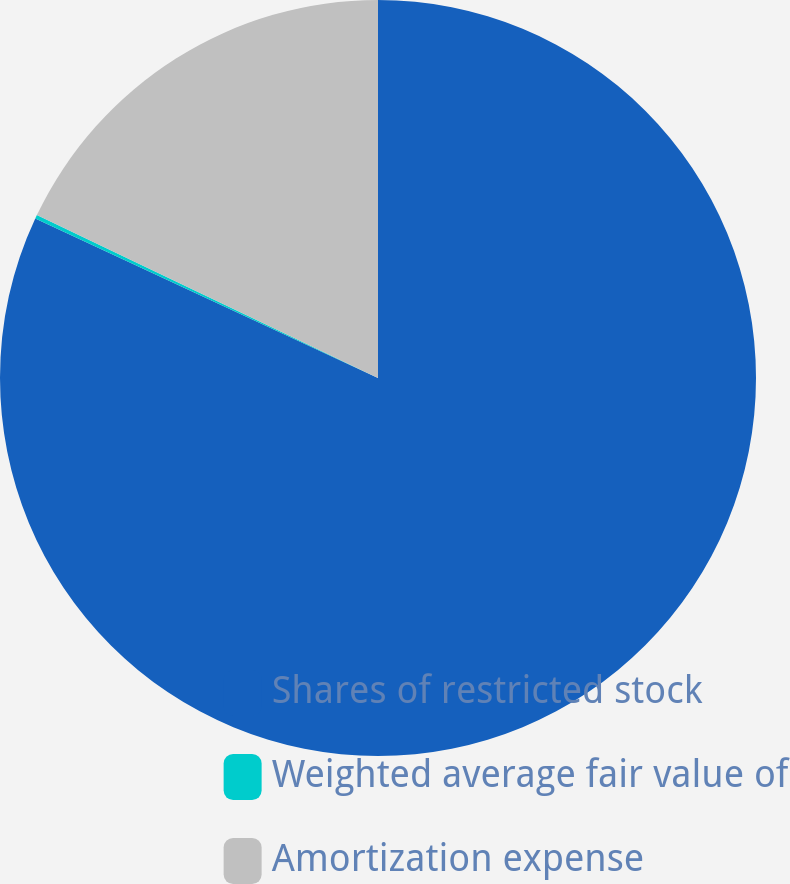Convert chart to OTSL. <chart><loc_0><loc_0><loc_500><loc_500><pie_chart><fcel>Shares of restricted stock<fcel>Weighted average fair value of<fcel>Amortization expense<nl><fcel>81.93%<fcel>0.16%<fcel>17.91%<nl></chart> 